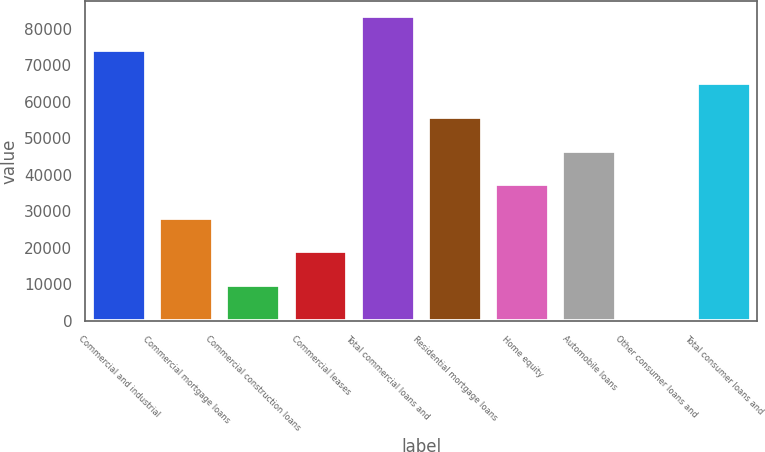Convert chart. <chart><loc_0><loc_0><loc_500><loc_500><bar_chart><fcel>Commercial and industrial<fcel>Commercial mortgage loans<fcel>Commercial construction loans<fcel>Commercial leases<fcel>Total commercial loans and<fcel>Residential mortgage loans<fcel>Home equity<fcel>Automobile loans<fcel>Other consumer loans and<fcel>Total consumer loans and<nl><fcel>74197<fcel>28234.5<fcel>9849.5<fcel>19042<fcel>83389.5<fcel>55812<fcel>37427<fcel>46619.5<fcel>657<fcel>65004.5<nl></chart> 